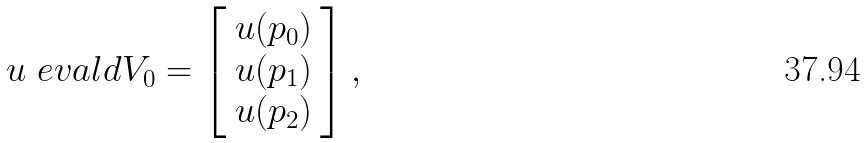<formula> <loc_0><loc_0><loc_500><loc_500>u \ e v a l d { V _ { 0 } } = \left [ \begin{array} { c } u ( p _ { 0 } ) \\ u ( p _ { 1 } ) \\ u ( p _ { 2 } ) \end{array} \right ] ,</formula> 